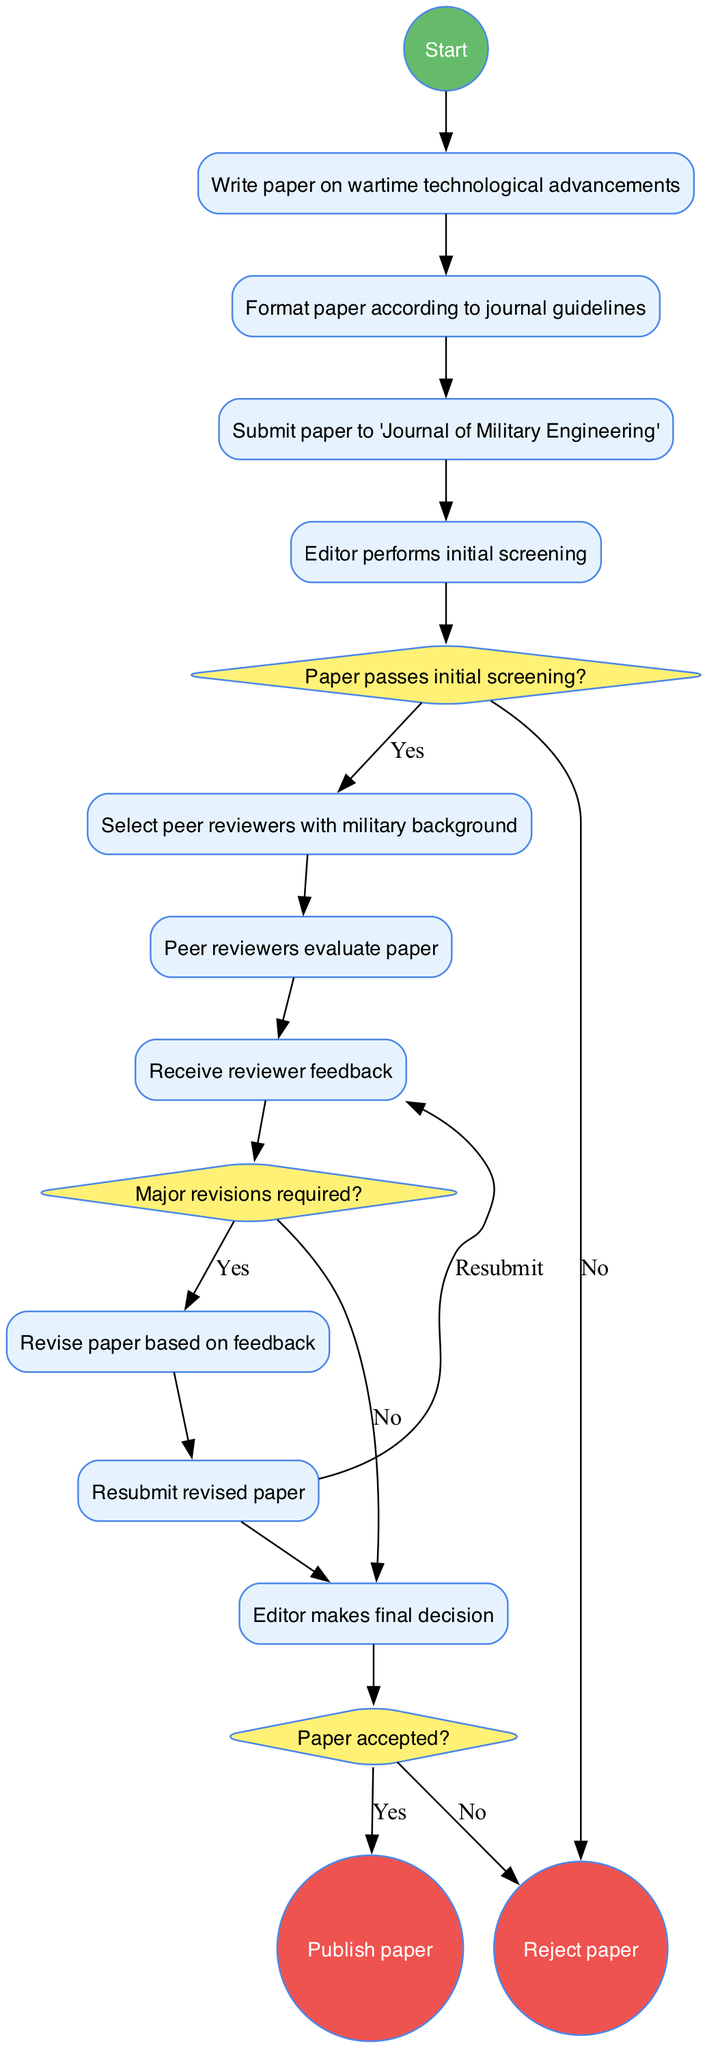What is the first activity in the diagram? The diagram starts with the "Begin research paper submission" node, leading to the first activity listed: "Write paper on wartime technological advancements."
Answer: Write paper on wartime technological advancements How many decision points are in the diagram? The diagram features three decision points that ask questions regarding the paper's status during the submission and review process.
Answer: Three What happens if the paper does not pass the initial screening? The flow indicates that if the paper fails the initial screening, it leads to the "Reject paper" node, showing that the submission process ends there.
Answer: Reject paper Which activity comes after receiving reviewer feedback? Following the node "Receive reviewer feedback," the next activity specified in the flow is "Revise paper based on feedback."
Answer: Revise paper based on feedback What is the final outcome if the paper is accepted? The diagram shows that if the paper is accepted, the final outcome is to "Publish paper," indicating a successful submission process.
Answer: Publish paper What does the decision point concerning major revisions require? The decision point about major revisions connects the "Receive reviewer feedback" activity to potential pathways where if major revisions are required, then the next step is to "Revise paper based on feedback."
Answer: Revise paper based on feedback What label is used for the edge leading to "Select peer reviewers with military background"? The edge that leads to "Select peer reviewers with military background" is directly connected to the node for passing the initial screening and does not have a label — it represents the outcome of a positive decision.
Answer: (no label) If major revisions are not required, what is the next step? If major revisions are not needed after receiving the feedback, the flow directly leads to the "Editor makes final decision" node, showcasing the subsequent course of action.
Answer: Editor makes final decision 